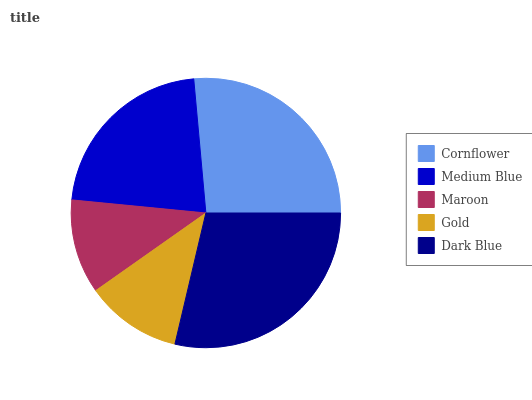Is Maroon the minimum?
Answer yes or no. Yes. Is Dark Blue the maximum?
Answer yes or no. Yes. Is Medium Blue the minimum?
Answer yes or no. No. Is Medium Blue the maximum?
Answer yes or no. No. Is Cornflower greater than Medium Blue?
Answer yes or no. Yes. Is Medium Blue less than Cornflower?
Answer yes or no. Yes. Is Medium Blue greater than Cornflower?
Answer yes or no. No. Is Cornflower less than Medium Blue?
Answer yes or no. No. Is Medium Blue the high median?
Answer yes or no. Yes. Is Medium Blue the low median?
Answer yes or no. Yes. Is Cornflower the high median?
Answer yes or no. No. Is Maroon the low median?
Answer yes or no. No. 